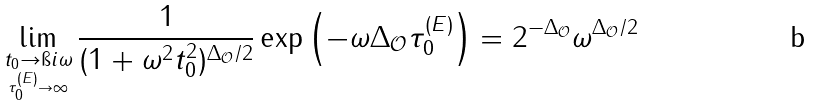Convert formula to latex. <formula><loc_0><loc_0><loc_500><loc_500>\lim _ { \underset { \tau ^ { ( E ) } _ { 0 } \rightarrow \infty } { t _ { 0 } \rightarrow \i i \omega } } \frac { 1 } { ( 1 + \omega ^ { 2 } t _ { 0 } ^ { 2 } ) ^ { \Delta _ { \mathcal { O } } / 2 } } \exp \left ( - \omega \Delta _ { \mathcal { O } } \tau ^ { ( E ) } _ { 0 } \right ) = 2 ^ { - \Delta _ { \mathcal { O } } } \omega ^ { \Delta _ { \mathcal { O } } / 2 }</formula> 